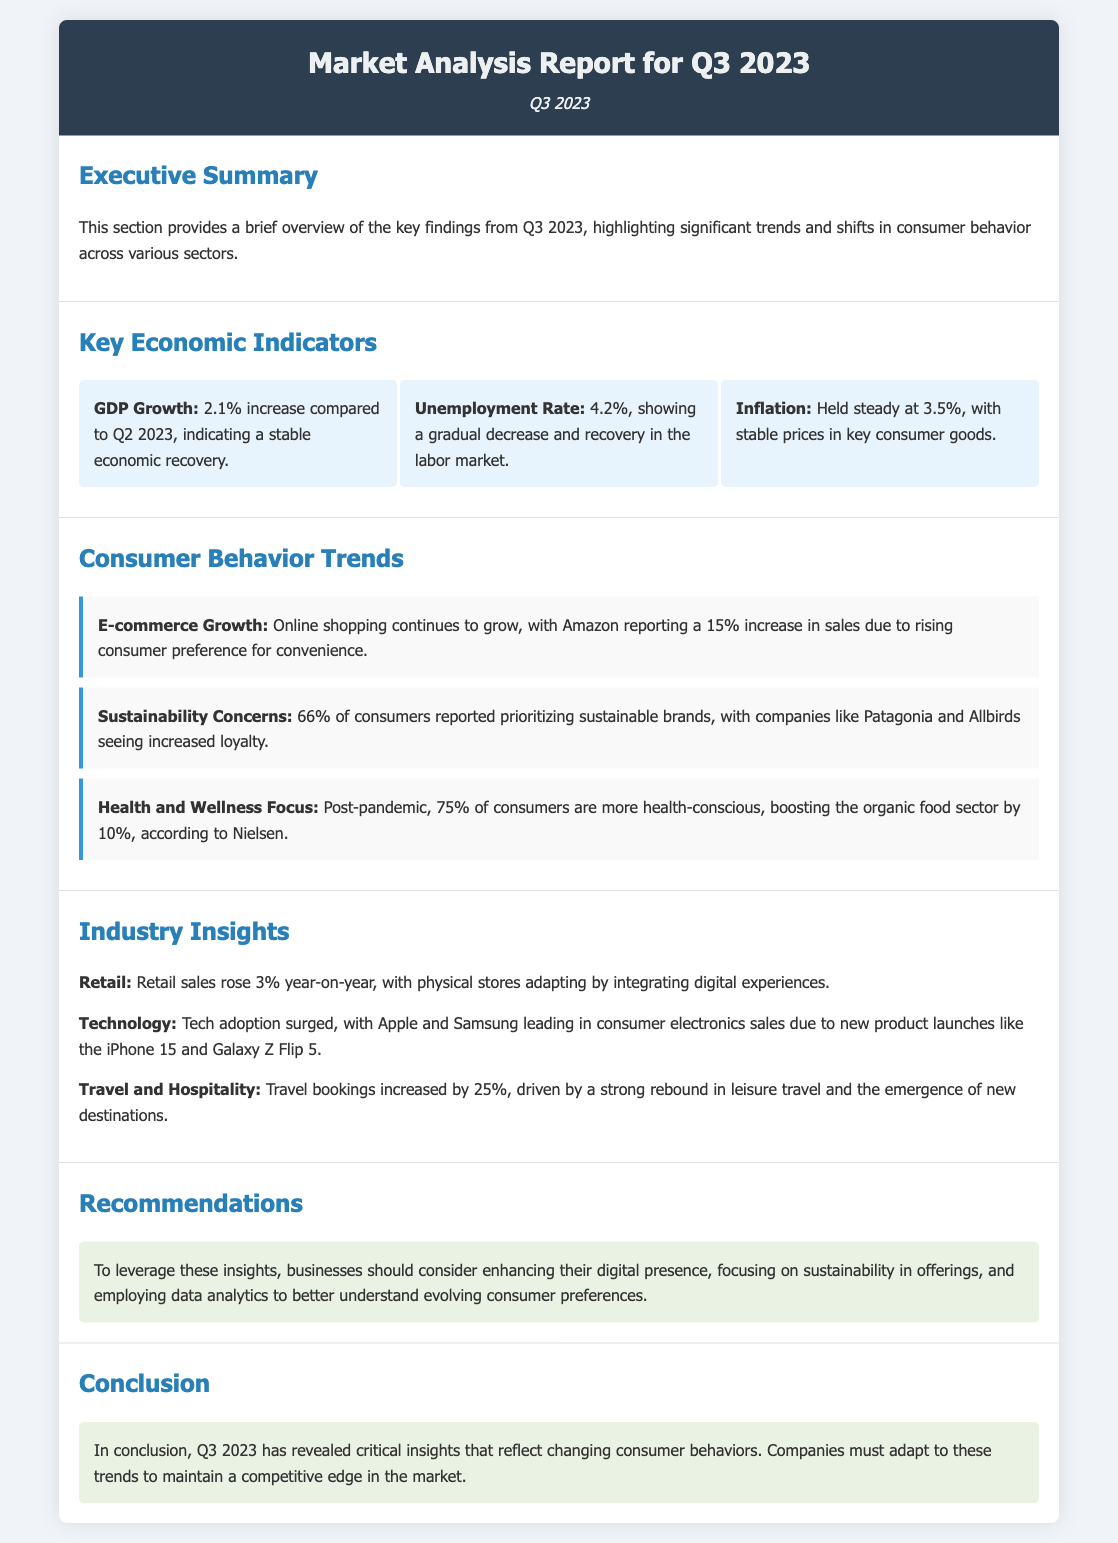What is the GDP growth for Q3 2023? The GDP growth is mentioned in the Key Economic Indicators section, which shows a 2.1% increase compared to Q2 2023.
Answer: 2.1% What percentage of consumers prioritized sustainable brands? This information is found in the Consumer Behavior Trends section, where 66% of consumers reported prioritizing sustainable brands.
Answer: 66% How much did travel bookings increase by? The increase in travel bookings is noted in the Industry Insights section, which states there was a 25% increase.
Answer: 25% What was the unemployment rate in Q3 2023? The unemployment rate is provided in the Key Economic Indicators section, showing it at 4.2%.
Answer: 4.2% Which two companies are mentioned as leaders in consumer electronics sales? The Industry Insights section cites Apple and Samsung as the leaders in consumer electronics sales.
Answer: Apple and Samsung What is the focus of 75% of consumers in Q3 2023? The Consumer Behavior Trends section reveals that 75% of consumers are more health-conscious post-pandemic.
Answer: Health-conscious What recommendation is given regarding digital presence? The Recommendations section suggests enhancing digital presence to leverage insights.
Answer: Enhance digital presence What was the year-on-year rise in retail sales? The Industry Insights section mentions that retail sales rose 3% year-on-year.
Answer: 3% 